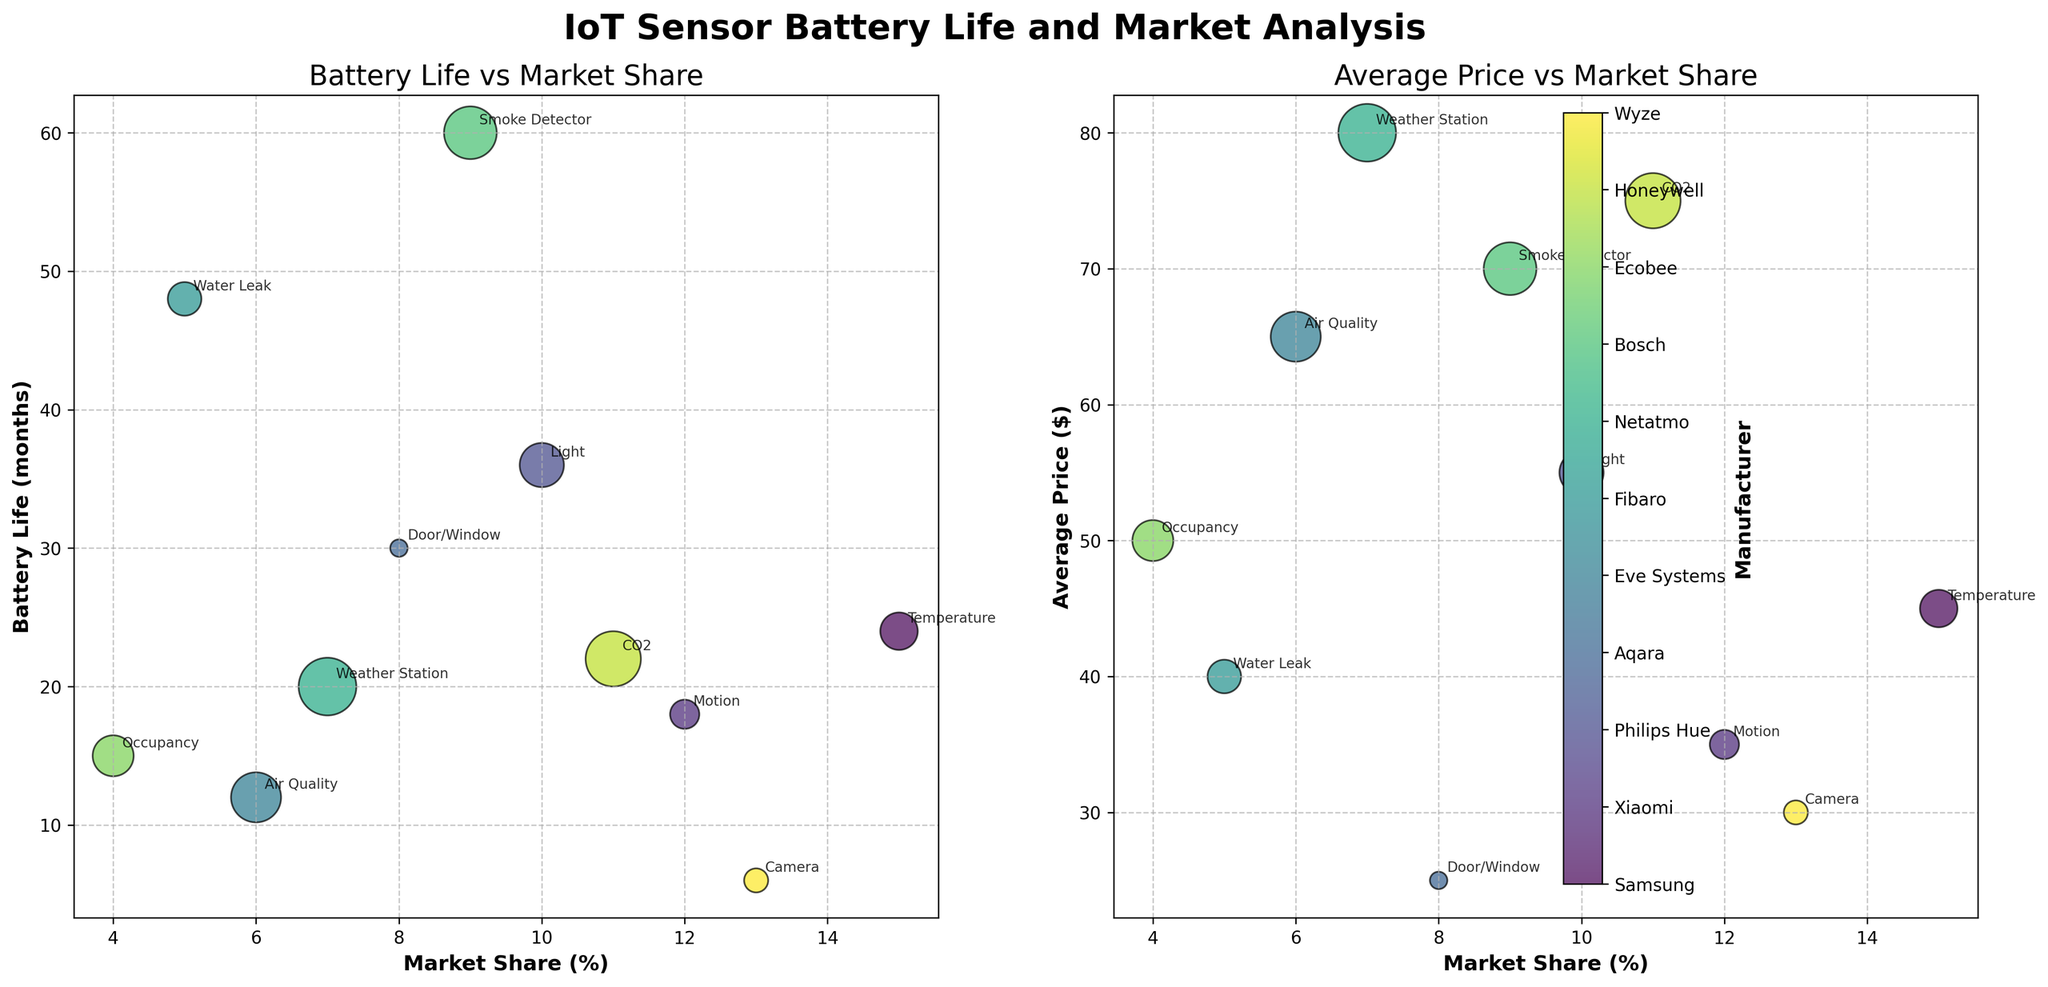Which manufacturer has the sensor with the longest battery life? Look for the highest value on the y-axis of the first subplot (Battery Life vs Market Share). The longest battery life is 60 months, corresponding to Bosch's Smoke Detector.
Answer: Bosch Which sensor types are related to Samsung and Xiaomi? Locate the annotations near the data points for Samsung and Xiaomi in either subplot. Samsung's sensor is labeled as Temperature, and Xiaomi's sensor is labeled as Motion.
Answer: Temperature and Motion What is the average price of sensors manufactured by companies with a market share greater than 10%? Identify the sensors with a market share greater than 10% from the x-axis labels in either subplot. This includes Samsung, Xiaomi, Honeywell, and Wyze. Their prices are $45, $35, $75, and $30, respectively. The average price can be calculated as (45 + 35 + 75 + 30) / 4 = $46.25.
Answer: $46.25 Which sensor has the highest average price? Look for the highest value on the y-axis of the second subplot (Average Price vs Market Share). The highest average price is $80, corresponding to Netatmo's Weather Station.
Answer: Netatmo's Weather Station Which two sensors have the closest battery life durations but different manufacturers? Compare the y-axis (Battery Life) values in the first subplot for sensors with similar values but different manufacturers. Aqara's Door/Window sensor (30 months) and Philips Hue's Light sensor (36 months) have close battery lives.
Answer: Aqara's Door/Window and Philips Hue's Light Is there a relationship between market share and battery life? Evaluate the trend in the first subplot (Battery Life vs Market Share). The data points are scattered without a clear trend, suggesting no strong relationship between market share and battery life.
Answer: No strong relationship Which manufacturer's sensor is the cheapest and what type is it? Find the smallest bubble in either subplot. The cheapest sensor has a price of $25, corresponding to Aqara's Door/Window sensor.
Answer: Aqara's Door/Window Which sensor type has the shortest battery life and what is its market share? Identify the lowest value on the y-axis of the first subplot (Battery Life vs Market Share). The shortest battery life is 6 months for the Camera sensor, associated with Wyze, which has a 13% market share.
Answer: Camera, 13% How many sensors are priced below $50, and which manufacturers do they belong to? Check the y-axis values of the second subplot (Average Price vs Market Share), count the data points below $50, and note their corresponding manufacturers. The sensors priced below $50 are of Samsung (Temperature), Xiaomi (Motion), Aqara (Door/Window), Wyze (Camera), and Fibaro (Water Leak).
Answer: 5 sensors: Samsung, Xiaomi, Aqara, Wyze, Fibaro 